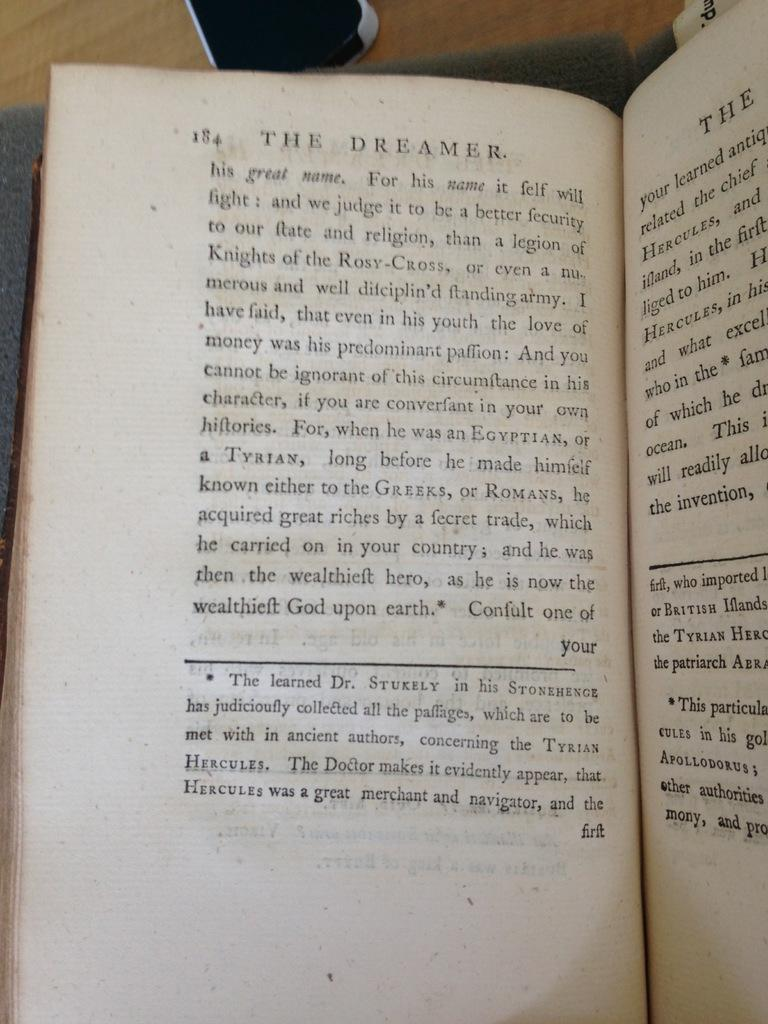<image>
Relay a brief, clear account of the picture shown. a picture of a book that is open to page 184 